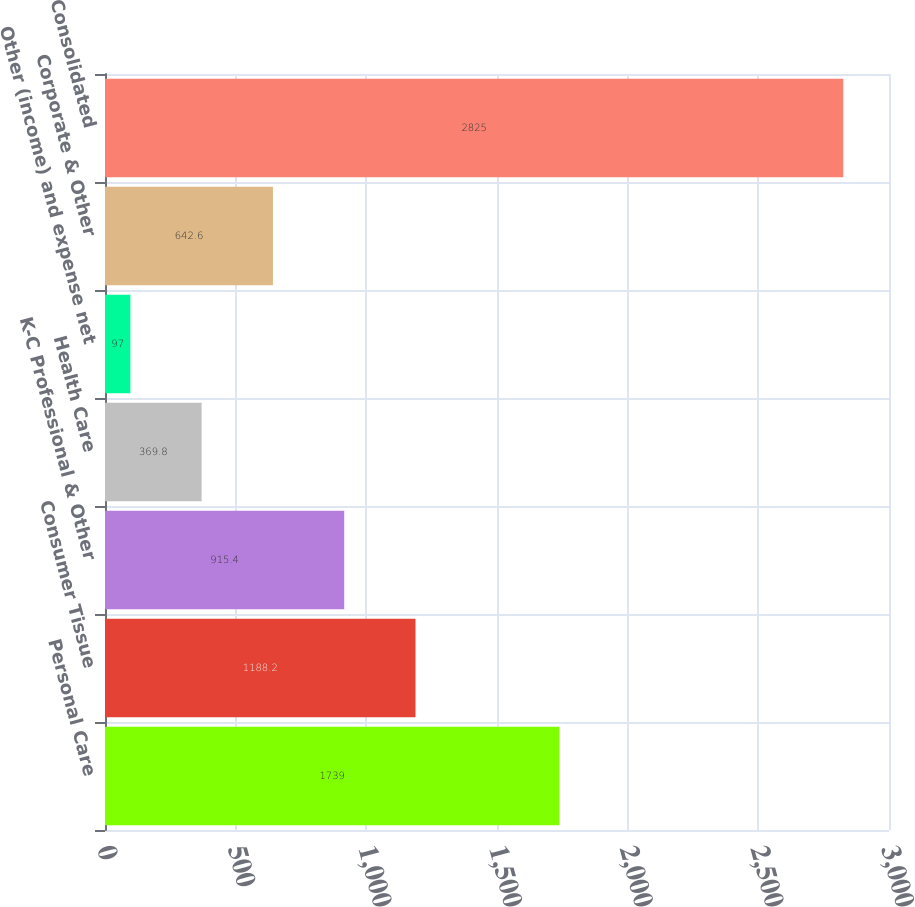<chart> <loc_0><loc_0><loc_500><loc_500><bar_chart><fcel>Personal Care<fcel>Consumer Tissue<fcel>K-C Professional & Other<fcel>Health Care<fcel>Other (income) and expense net<fcel>Corporate & Other<fcel>Consolidated<nl><fcel>1739<fcel>1188.2<fcel>915.4<fcel>369.8<fcel>97<fcel>642.6<fcel>2825<nl></chart> 